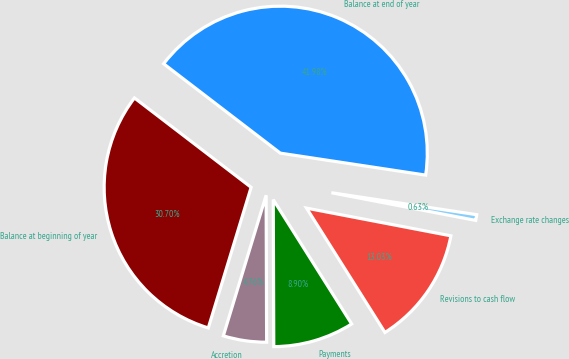Convert chart to OTSL. <chart><loc_0><loc_0><loc_500><loc_500><pie_chart><fcel>Balance at beginning of year<fcel>Accretion<fcel>Payments<fcel>Revisions to cash flow<fcel>Exchange rate changes<fcel>Balance at end of year<nl><fcel>30.7%<fcel>4.76%<fcel>8.9%<fcel>13.03%<fcel>0.63%<fcel>41.98%<nl></chart> 